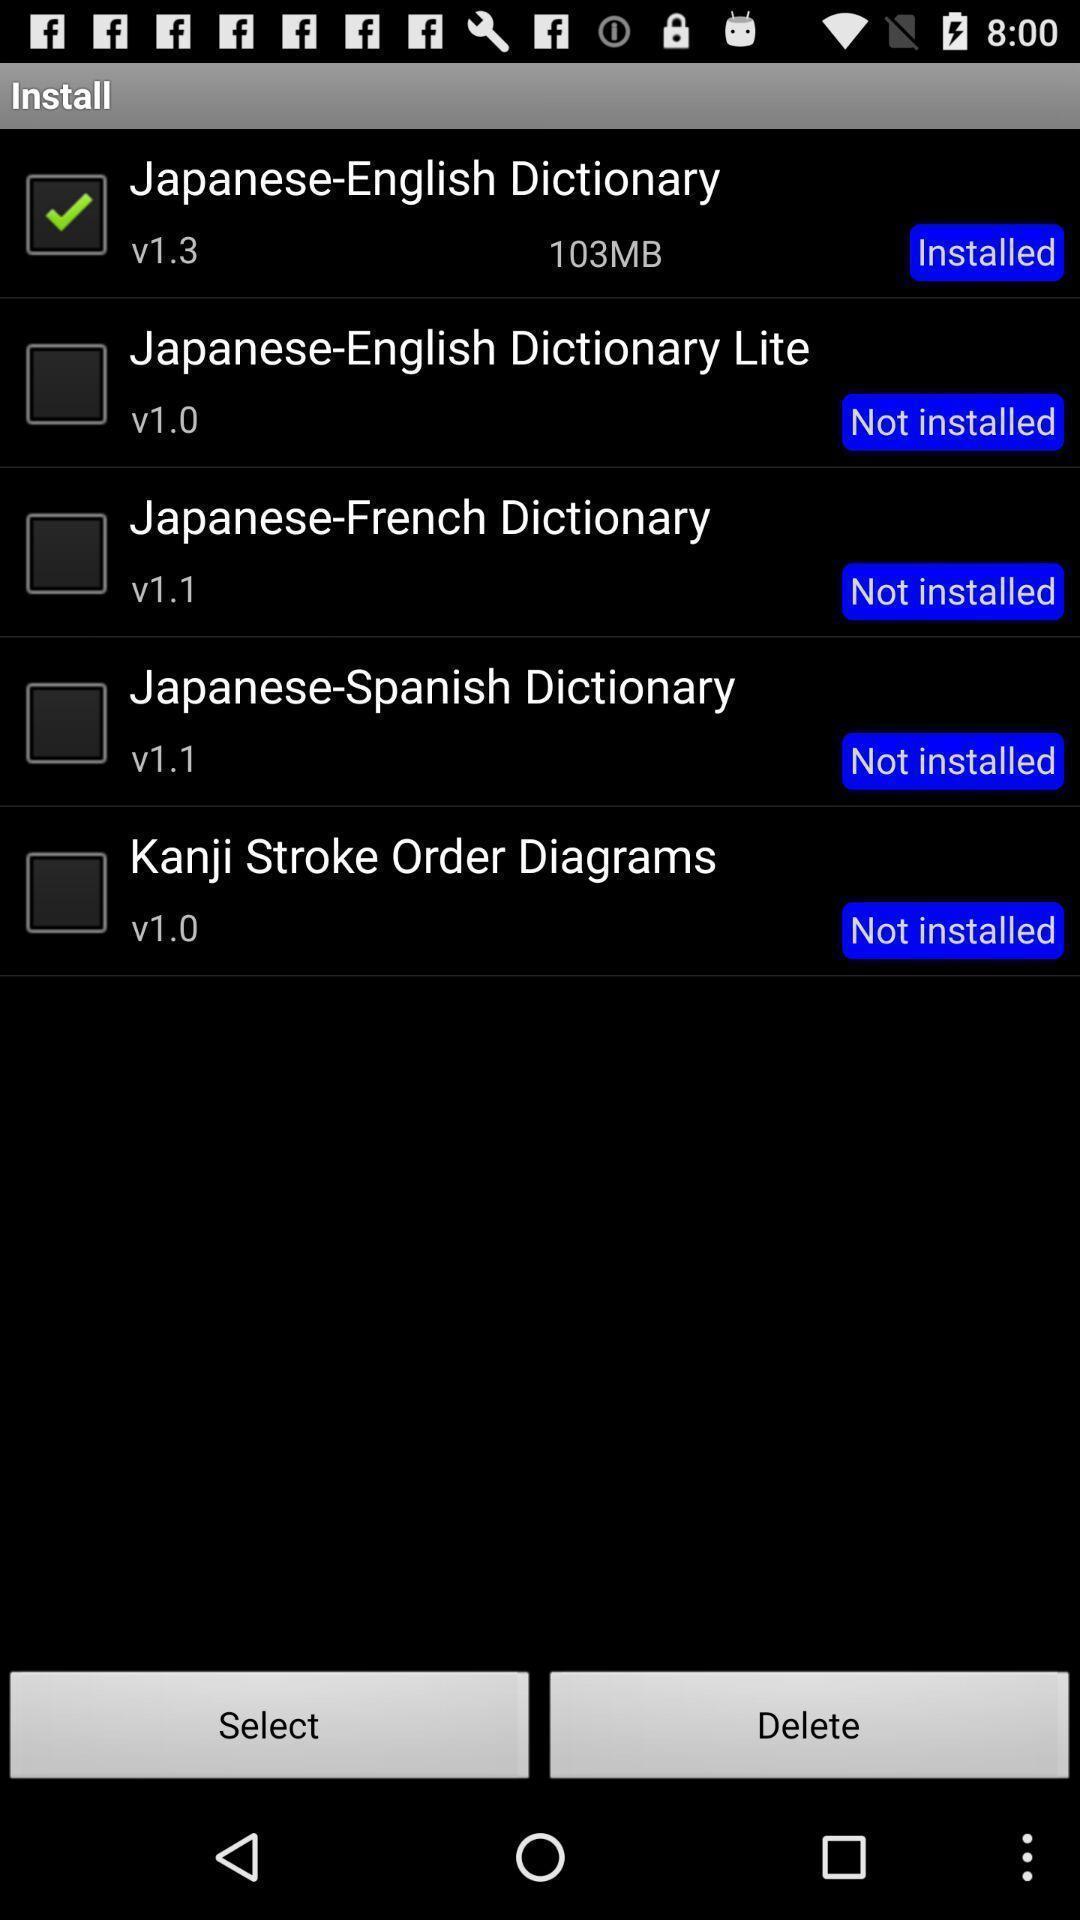Tell me what you see in this picture. Screen showing list of dictionaries. 